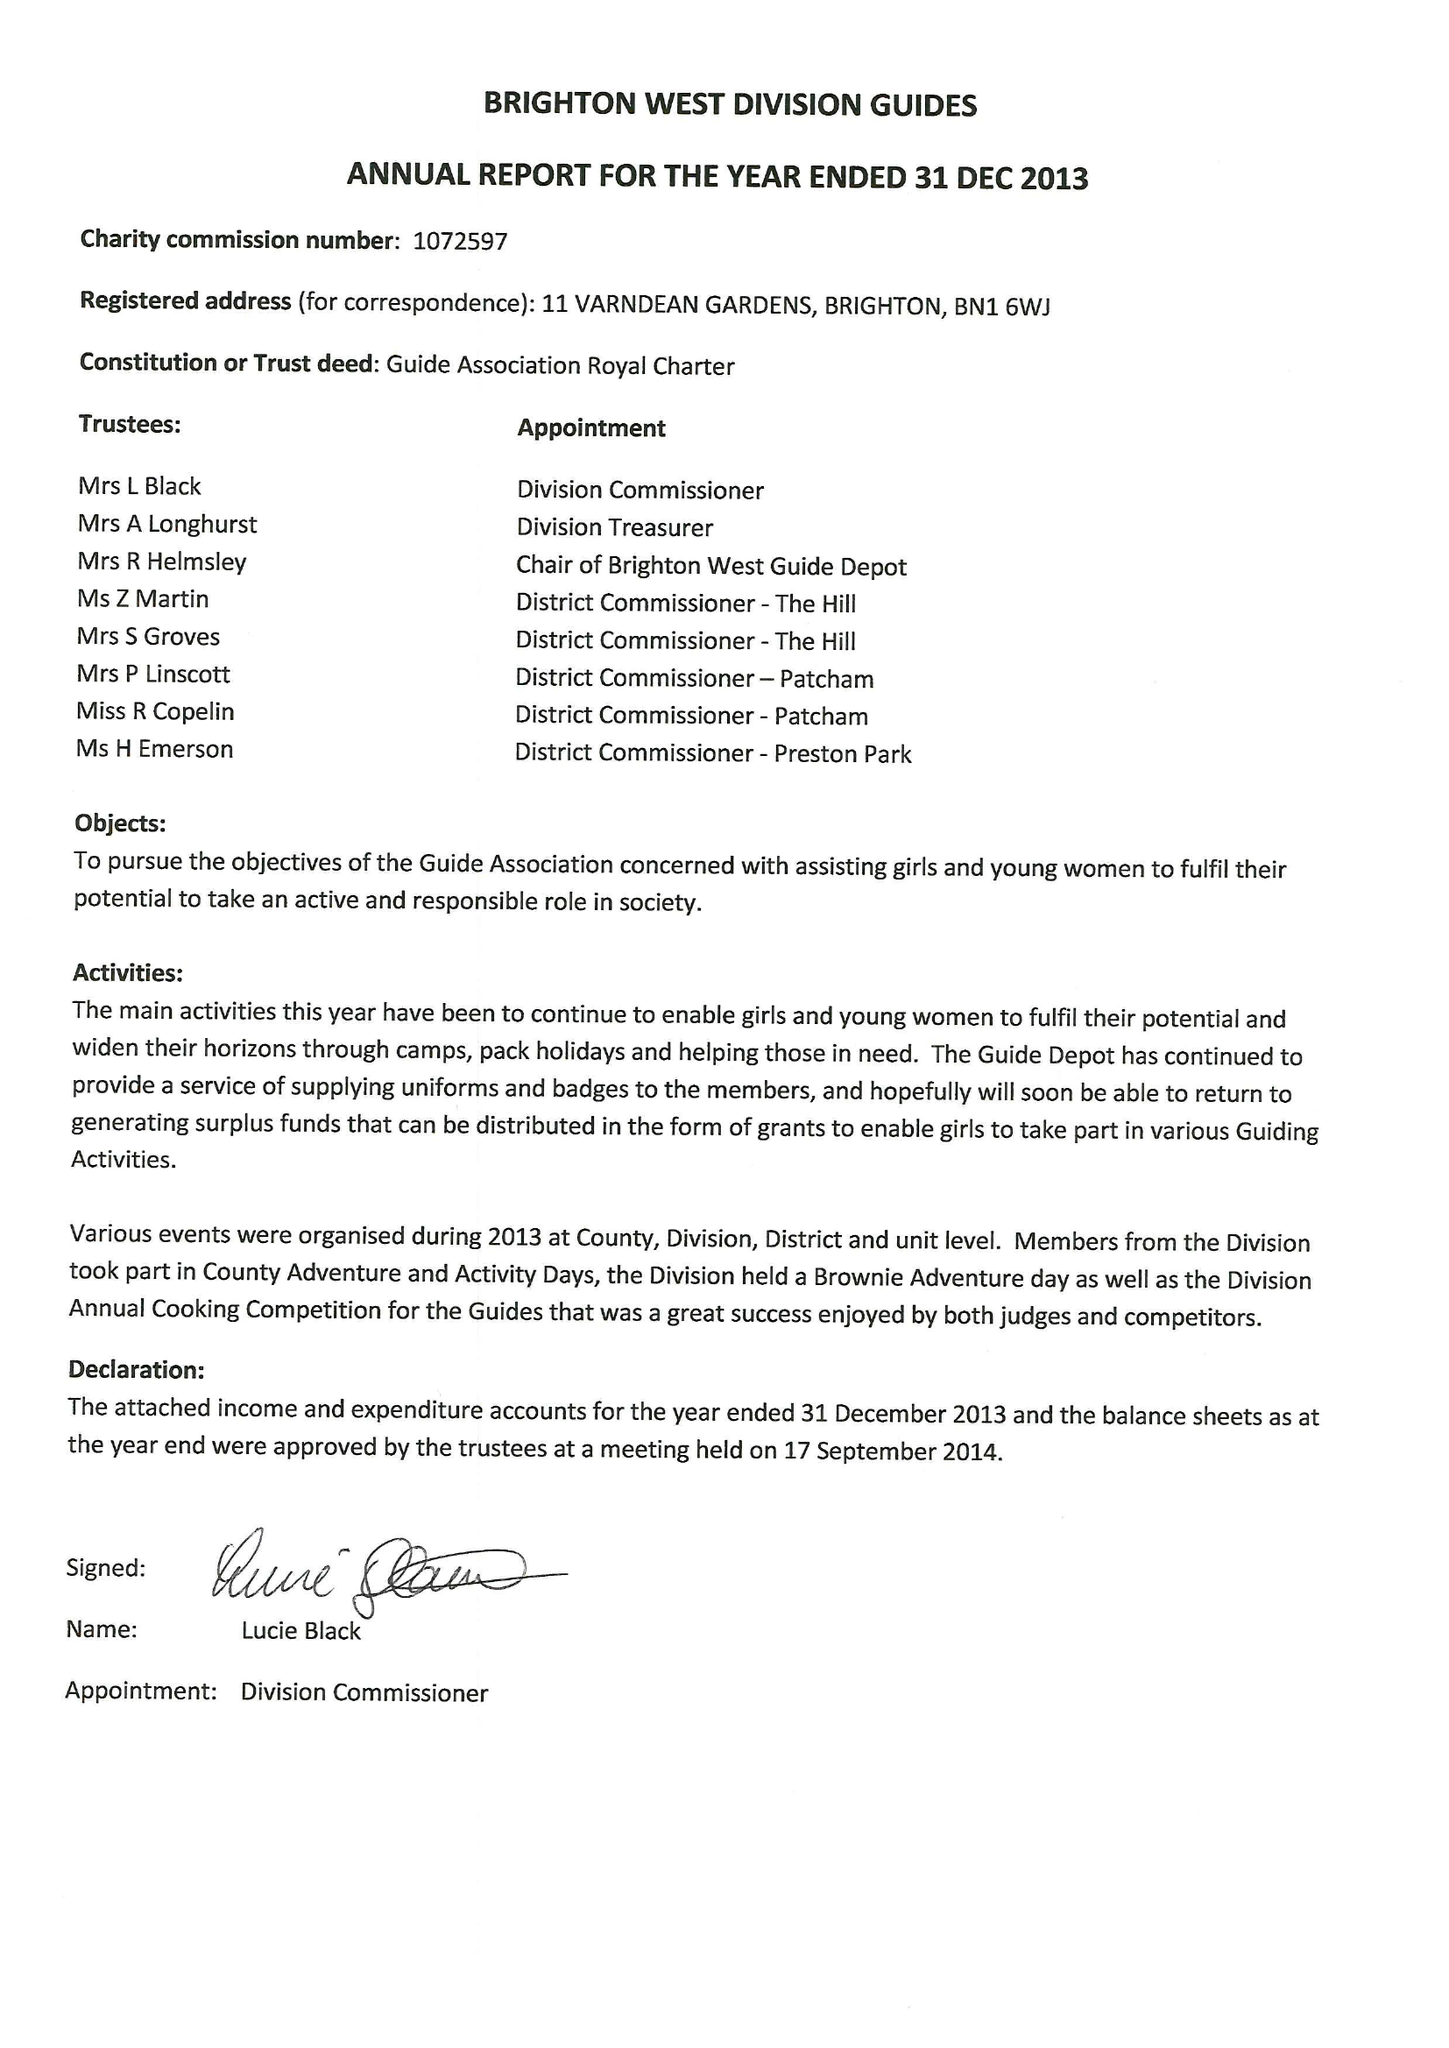What is the value for the report_date?
Answer the question using a single word or phrase. 2013-12-31 